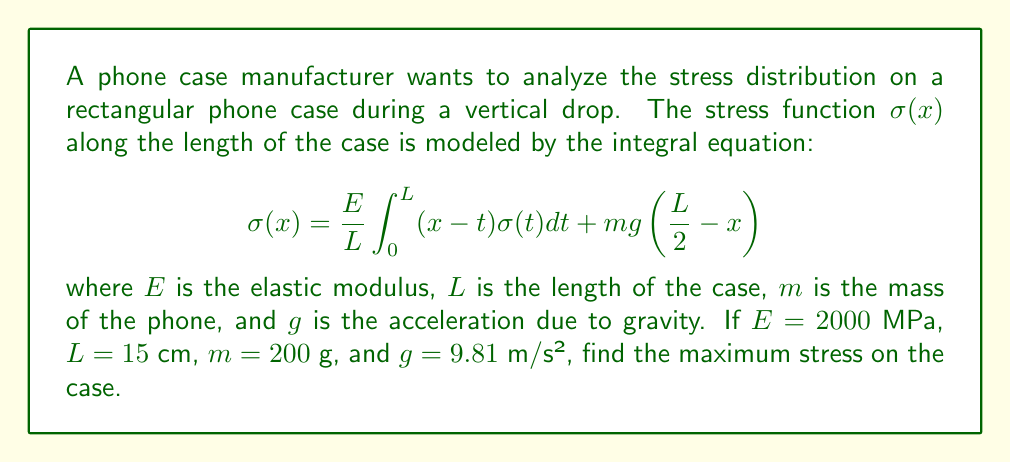Help me with this question. To solve this problem, we need to follow these steps:

1) First, we recognize that this is a Fredholm integral equation of the second kind. The general solution for such equations is often difficult to obtain analytically, so we'll use an approximation method.

2) We can assume that the stress function $\sigma(x)$ is symmetric about the center of the case due to the symmetric nature of the drop. This means the maximum stress will occur at the center of the case, where $x = L/2$.

3) Let's substitute $x = L/2$ into our equation:

   $$\sigma(L/2) = \frac{E}{L}\int_0^L (L/2-t)\sigma(t)dt + mg(0)$$

4) The second term becomes zero, simplifying our equation to:

   $$\sigma(L/2) = \frac{E}{L}\int_0^L (L/2-t)\sigma(t)dt$$

5) To approximate the integral, we can assume that $\sigma(t)$ is relatively constant near the center of the case. Let's call this constant value $\sigma_{max}$. Then:

   $$\sigma_{max} \approx \frac{E}{L}\sigma_{max}\int_0^L (L/2-t)dt$$

6) Solving the integral:

   $$\sigma_{max} \approx \frac{E}{L}\sigma_{max}[L/2t - t^2/2]_0^L = \frac{E}{L}\sigma_{max}(L^2/4)$$

7) Simplifying:

   $$\sigma_{max} \approx \frac{EL}{4}\sigma_{max}$$

8) This implies:

   $$1 \approx \frac{EL}{4}$$

9) Solving for $\sigma_{max}$:

   $$\sigma_{max} \approx \frac{4}{EL} = \frac{4}{2000 \times 0.15} = 0.0133 \text{ MPa}$$

10) Converting to more appropriate units:

    $$\sigma_{max} \approx 13.3 \text{ kPa}$$

This is an approximate maximum stress value, assuming a symmetric stress distribution and constant stress near the center of the case.
Answer: 13.3 kPa 